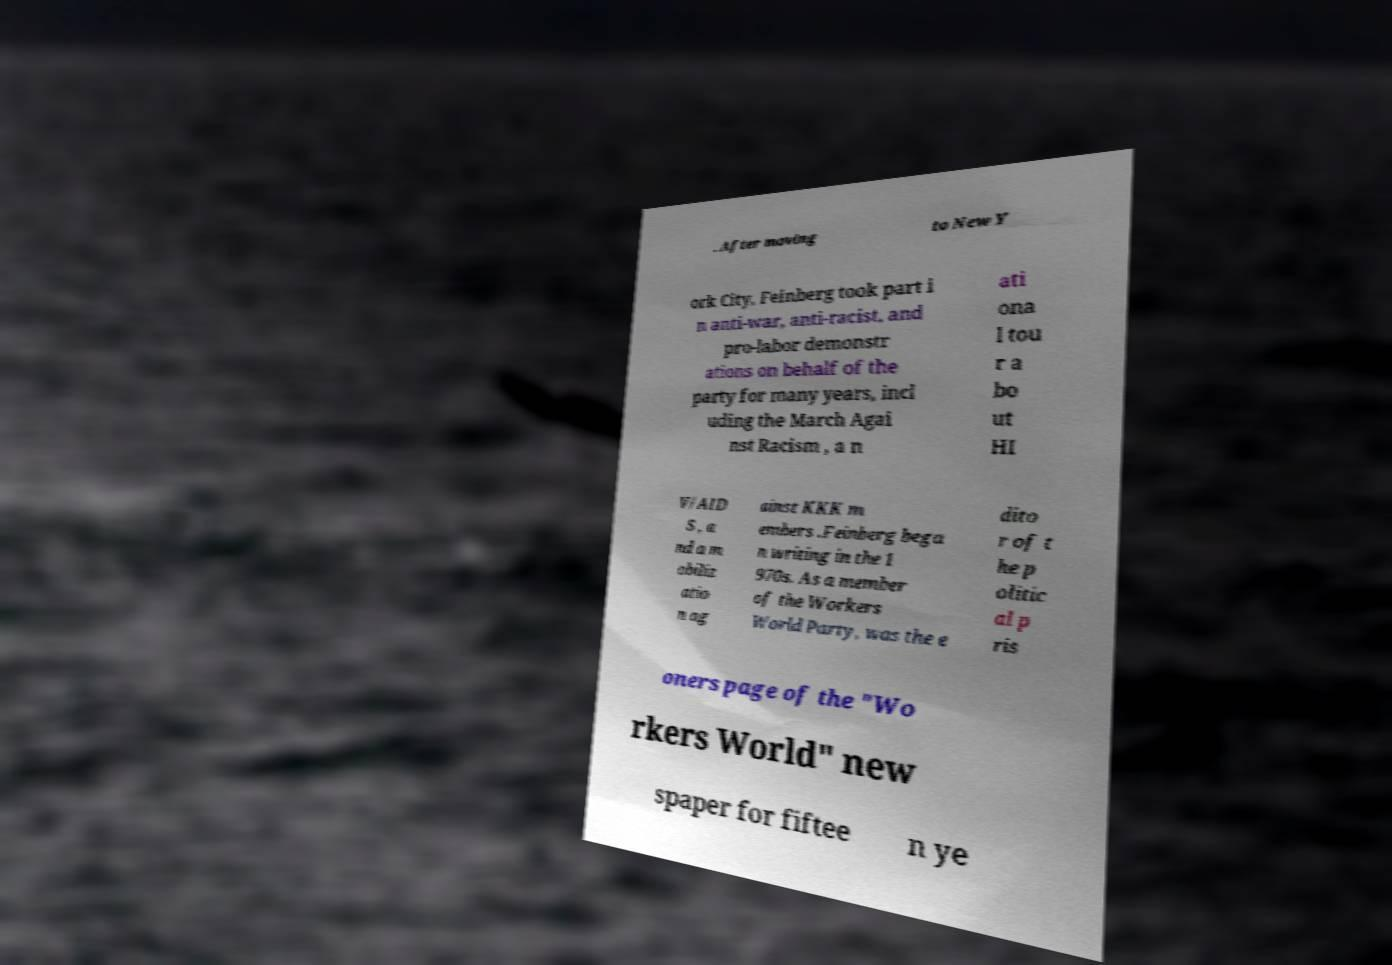What messages or text are displayed in this image? I need them in a readable, typed format. . After moving to New Y ork City, Feinberg took part i n anti-war, anti-racist, and pro-labor demonstr ations on behalf of the party for many years, incl uding the March Agai nst Racism , a n ati ona l tou r a bo ut HI V/AID S , a nd a m obiliz atio n ag ainst KKK m embers .Feinberg bega n writing in the 1 970s. As a member of the Workers World Party, was the e dito r of t he p olitic al p ris oners page of the "Wo rkers World" new spaper for fiftee n ye 